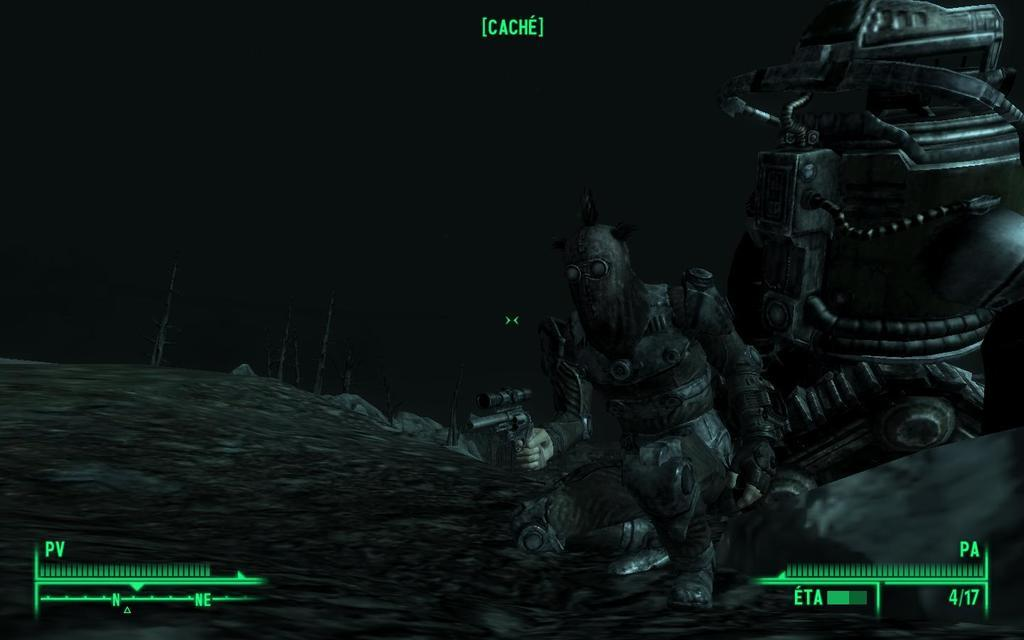What type of image is being described? The image is a cartoon. Who or what can be seen in the image? There are men in the image. What type of terrain is present in the image? There is land in the image. What type of vegetation is present in the image? There are trees in the image. What part of the natural environment is visible in the image? There is sky visible in the image. What type of locket is being worn by the trees in the image? There are no lockets present in the image, as the subjects are men and trees, not people wearing jewelry. 